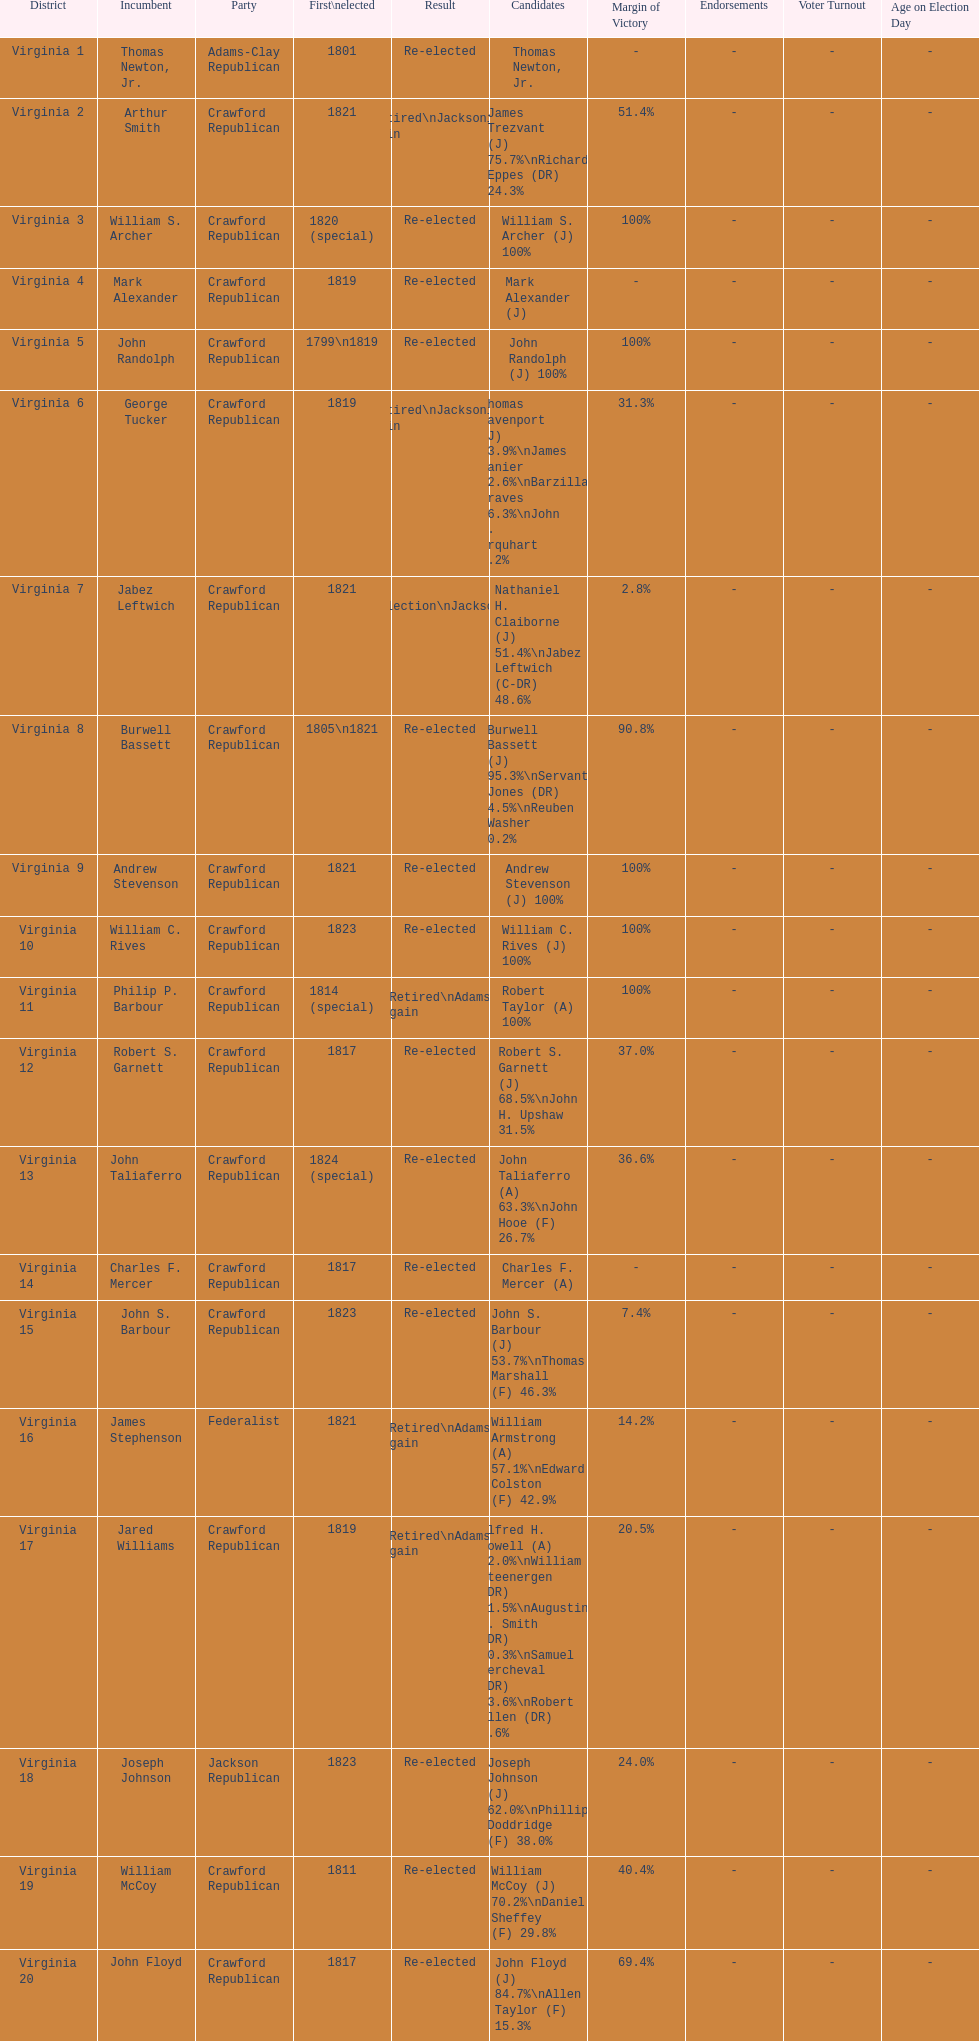Who was the next incumbent after john randolph? George Tucker. 